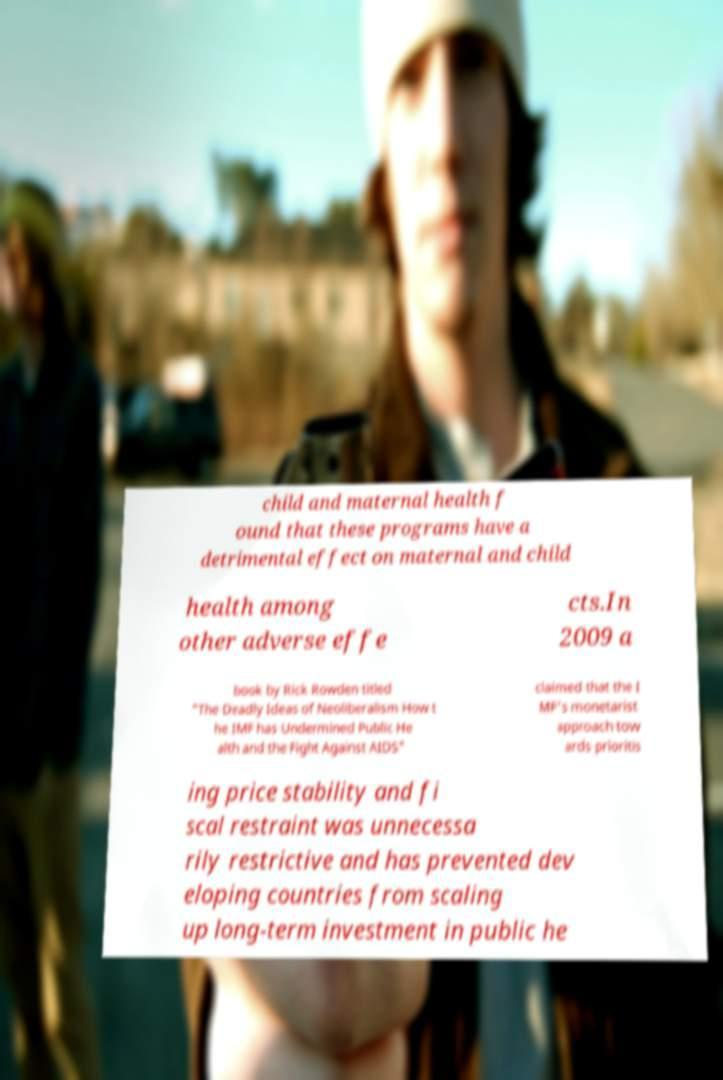Can you accurately transcribe the text from the provided image for me? child and maternal health f ound that these programs have a detrimental effect on maternal and child health among other adverse effe cts.In 2009 a book by Rick Rowden titled "The Deadly Ideas of Neoliberalism How t he IMF has Undermined Public He alth and the Fight Against AIDS" claimed that the I MF's monetarist approach tow ards prioritis ing price stability and fi scal restraint was unnecessa rily restrictive and has prevented dev eloping countries from scaling up long-term investment in public he 